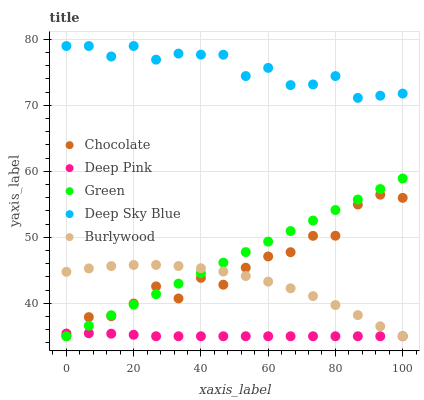Does Deep Pink have the minimum area under the curve?
Answer yes or no. Yes. Does Deep Sky Blue have the maximum area under the curve?
Answer yes or no. Yes. Does Green have the minimum area under the curve?
Answer yes or no. No. Does Green have the maximum area under the curve?
Answer yes or no. No. Is Green the smoothest?
Answer yes or no. Yes. Is Chocolate the roughest?
Answer yes or no. Yes. Is Deep Pink the smoothest?
Answer yes or no. No. Is Deep Pink the roughest?
Answer yes or no. No. Does Burlywood have the lowest value?
Answer yes or no. Yes. Does Deep Sky Blue have the lowest value?
Answer yes or no. No. Does Deep Sky Blue have the highest value?
Answer yes or no. Yes. Does Green have the highest value?
Answer yes or no. No. Is Burlywood less than Deep Sky Blue?
Answer yes or no. Yes. Is Deep Sky Blue greater than Deep Pink?
Answer yes or no. Yes. Does Deep Pink intersect Chocolate?
Answer yes or no. Yes. Is Deep Pink less than Chocolate?
Answer yes or no. No. Is Deep Pink greater than Chocolate?
Answer yes or no. No. Does Burlywood intersect Deep Sky Blue?
Answer yes or no. No. 